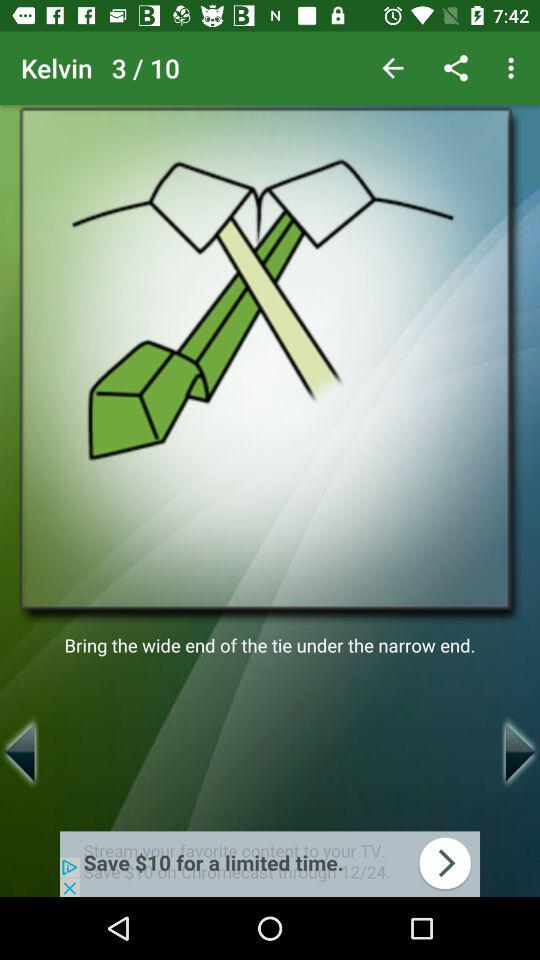What is the total number of images? The total number of images is 10. 